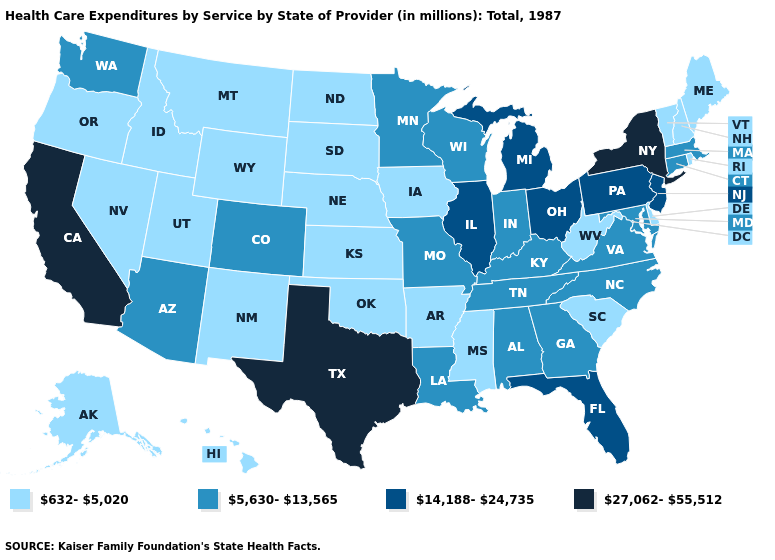Name the states that have a value in the range 5,630-13,565?
Short answer required. Alabama, Arizona, Colorado, Connecticut, Georgia, Indiana, Kentucky, Louisiana, Maryland, Massachusetts, Minnesota, Missouri, North Carolina, Tennessee, Virginia, Washington, Wisconsin. What is the highest value in the Northeast ?
Answer briefly. 27,062-55,512. Name the states that have a value in the range 632-5,020?
Write a very short answer. Alaska, Arkansas, Delaware, Hawaii, Idaho, Iowa, Kansas, Maine, Mississippi, Montana, Nebraska, Nevada, New Hampshire, New Mexico, North Dakota, Oklahoma, Oregon, Rhode Island, South Carolina, South Dakota, Utah, Vermont, West Virginia, Wyoming. What is the lowest value in the USA?
Answer briefly. 632-5,020. Name the states that have a value in the range 14,188-24,735?
Short answer required. Florida, Illinois, Michigan, New Jersey, Ohio, Pennsylvania. Which states hav the highest value in the West?
Keep it brief. California. Among the states that border Texas , does New Mexico have the lowest value?
Keep it brief. Yes. What is the value of Alaska?
Short answer required. 632-5,020. What is the value of Delaware?
Be succinct. 632-5,020. Does Texas have the highest value in the South?
Keep it brief. Yes. What is the value of Rhode Island?
Be succinct. 632-5,020. Name the states that have a value in the range 27,062-55,512?
Write a very short answer. California, New York, Texas. Which states have the lowest value in the Northeast?
Concise answer only. Maine, New Hampshire, Rhode Island, Vermont. 